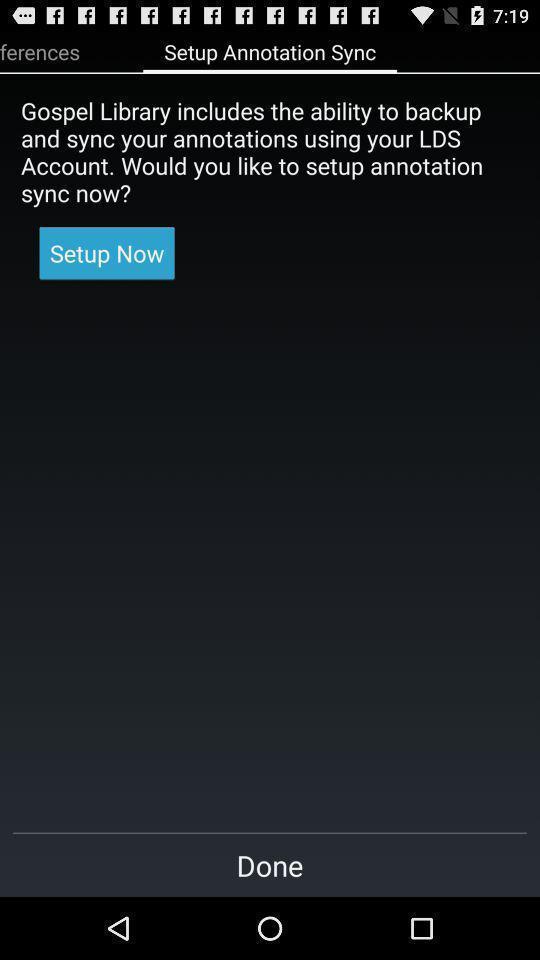Tell me what you see in this picture. Setup page in a holy book reading app. 